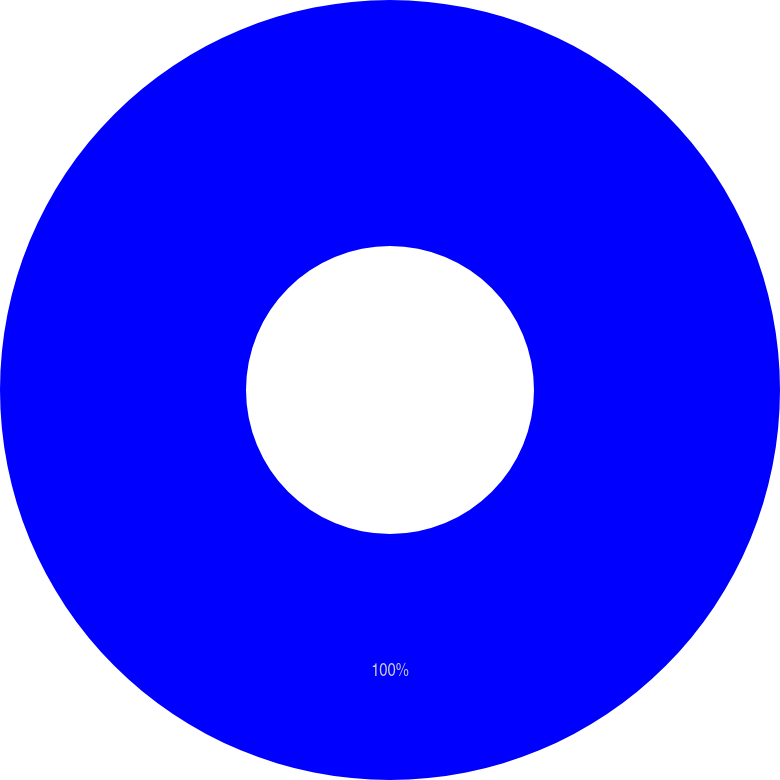Convert chart to OTSL. <chart><loc_0><loc_0><loc_500><loc_500><pie_chart><ecel><nl><fcel>100.0%<nl></chart> 